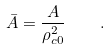Convert formula to latex. <formula><loc_0><loc_0><loc_500><loc_500>\bar { A } = \frac { A } { \rho _ { c 0 } ^ { 2 } } \quad .</formula> 